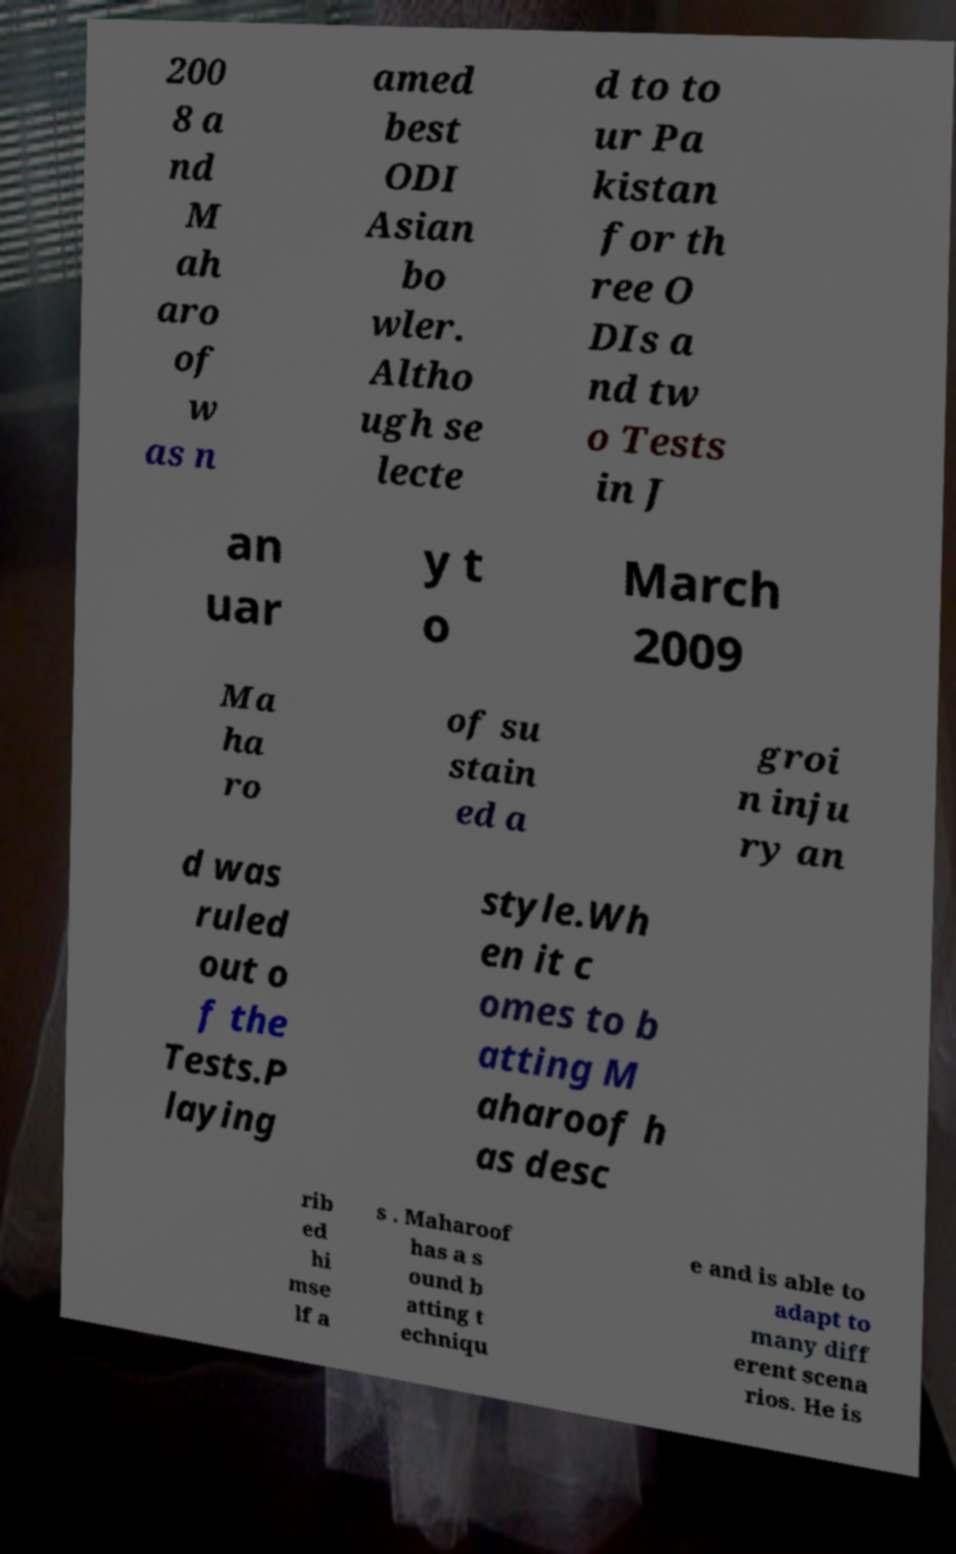Could you extract and type out the text from this image? 200 8 a nd M ah aro of w as n amed best ODI Asian bo wler. Altho ugh se lecte d to to ur Pa kistan for th ree O DIs a nd tw o Tests in J an uar y t o March 2009 Ma ha ro of su stain ed a groi n inju ry an d was ruled out o f the Tests.P laying style.Wh en it c omes to b atting M aharoof h as desc rib ed hi mse lf a s . Maharoof has a s ound b atting t echniqu e and is able to adapt to many diff erent scena rios. He is 